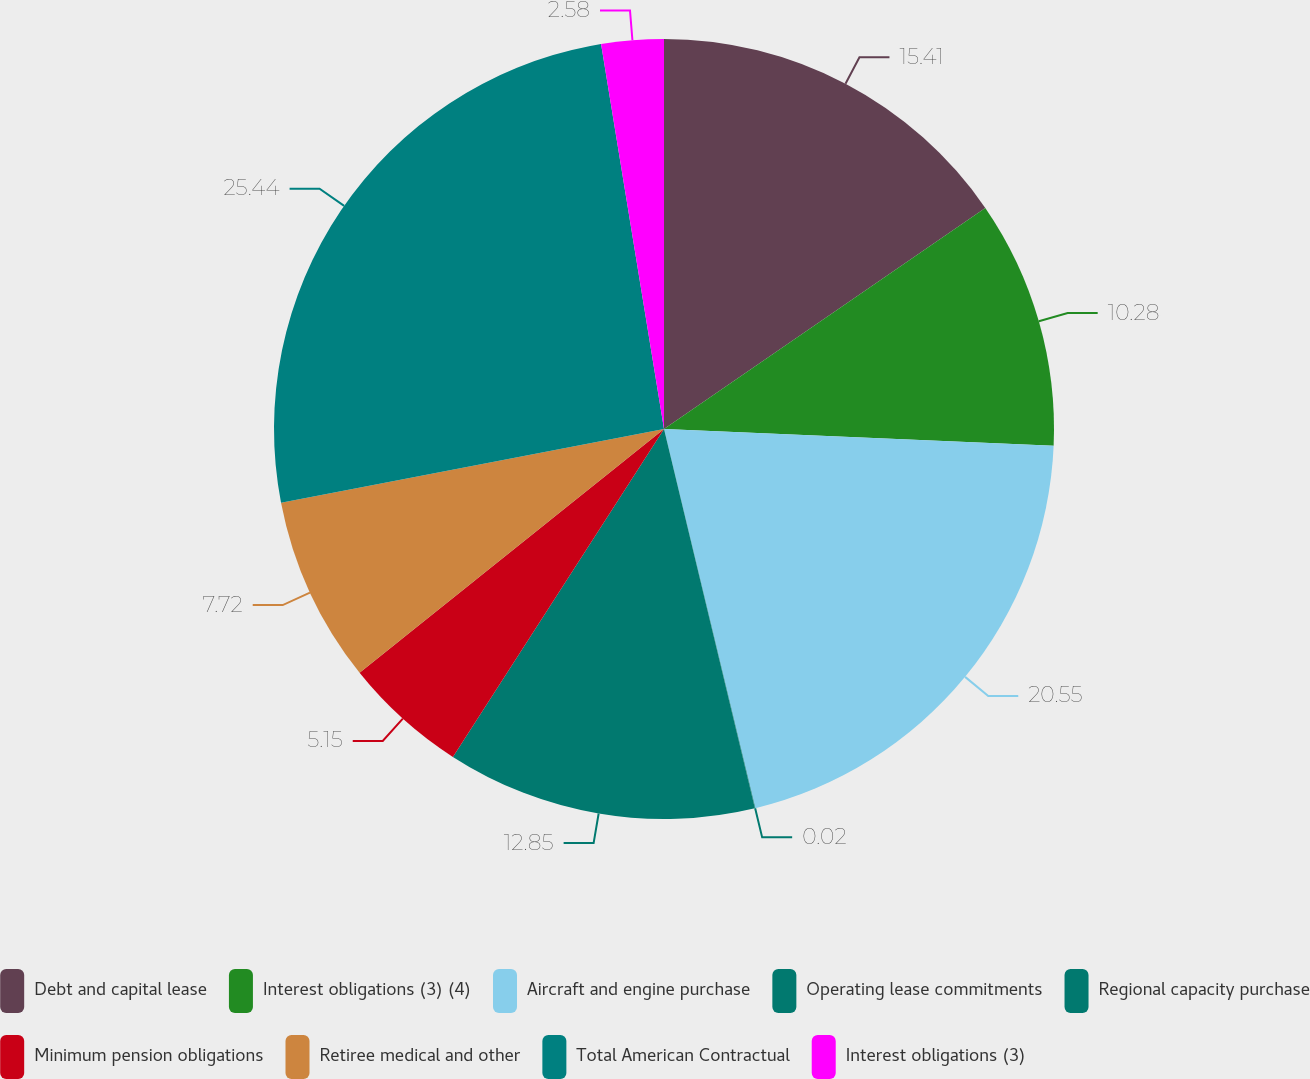Convert chart to OTSL. <chart><loc_0><loc_0><loc_500><loc_500><pie_chart><fcel>Debt and capital lease<fcel>Interest obligations (3) (4)<fcel>Aircraft and engine purchase<fcel>Operating lease commitments<fcel>Regional capacity purchase<fcel>Minimum pension obligations<fcel>Retiree medical and other<fcel>Total American Contractual<fcel>Interest obligations (3)<nl><fcel>15.41%<fcel>10.28%<fcel>20.55%<fcel>0.02%<fcel>12.85%<fcel>5.15%<fcel>7.72%<fcel>25.45%<fcel>2.58%<nl></chart> 